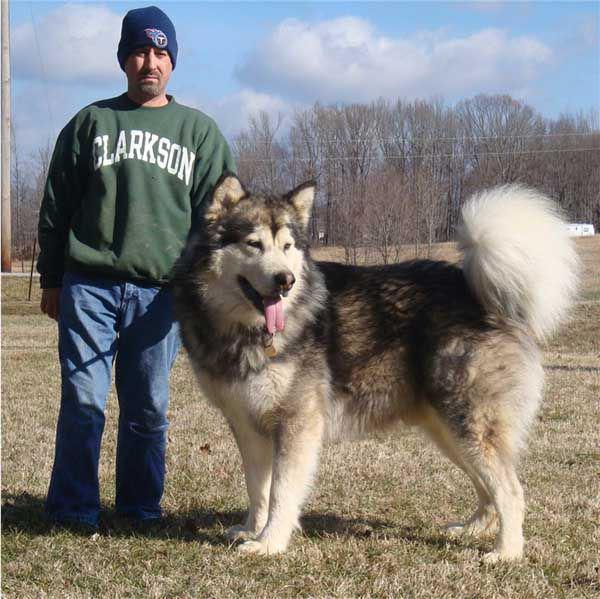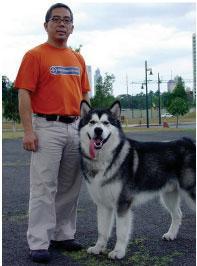The first image is the image on the left, the second image is the image on the right. Evaluate the accuracy of this statement regarding the images: "The left and right image contains the same number of dogs.". Is it true? Answer yes or no. Yes. The first image is the image on the left, the second image is the image on the right. Evaluate the accuracy of this statement regarding the images: "In the right image, a little girl is hugging a big dog and laying the side of her head against it.". Is it true? Answer yes or no. No. 